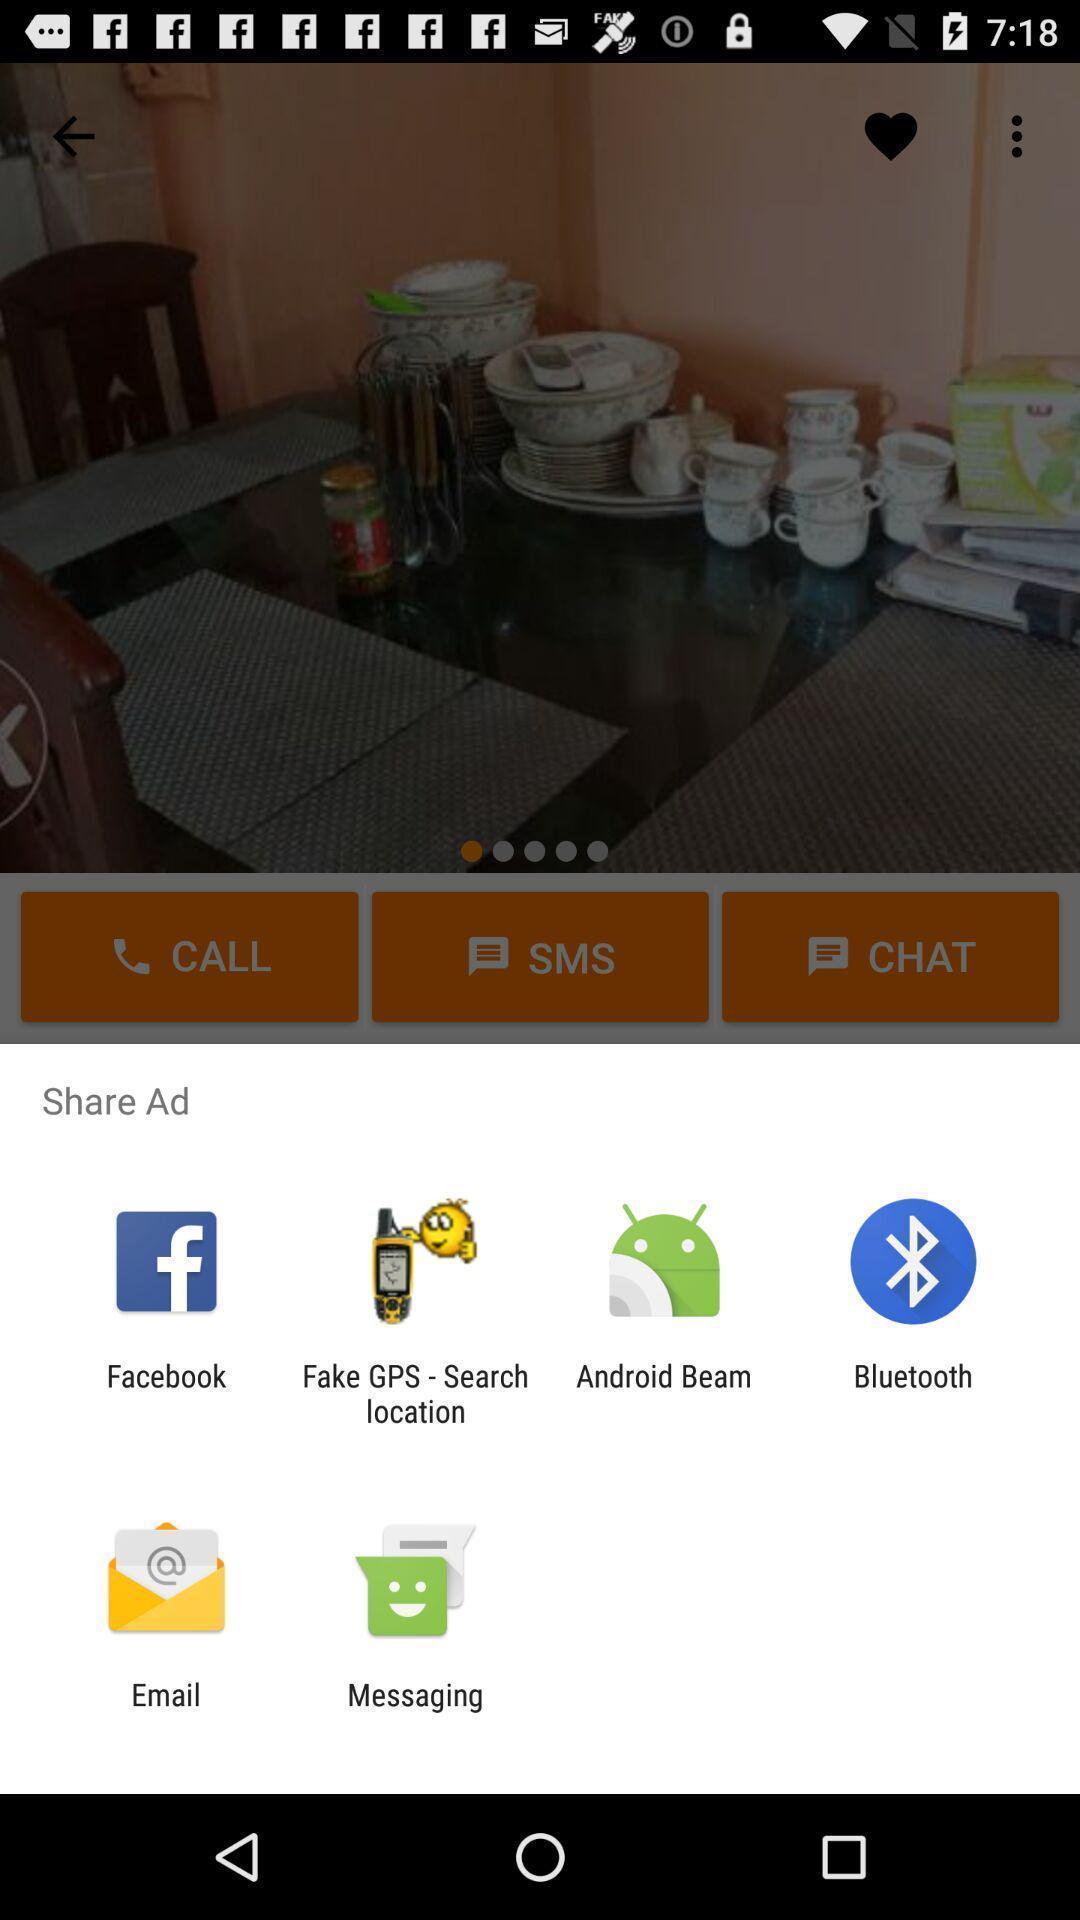Describe the visual elements of this screenshot. Pop-up showing the various app to share the advertisement. 